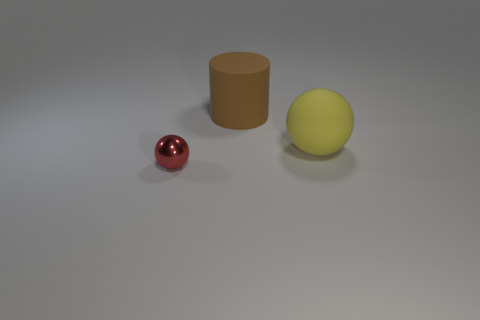Subtract all red spheres. How many spheres are left? 1 Add 1 large gray matte spheres. How many objects exist? 4 Subtract 1 spheres. How many spheres are left? 1 Subtract all cylinders. How many objects are left? 2 Subtract 1 yellow spheres. How many objects are left? 2 Subtract all blue cylinders. Subtract all cyan balls. How many cylinders are left? 1 Subtract all yellow blocks. How many blue cylinders are left? 0 Subtract all green spheres. Subtract all big matte objects. How many objects are left? 1 Add 2 large brown rubber cylinders. How many large brown rubber cylinders are left? 3 Add 1 big matte spheres. How many big matte spheres exist? 2 